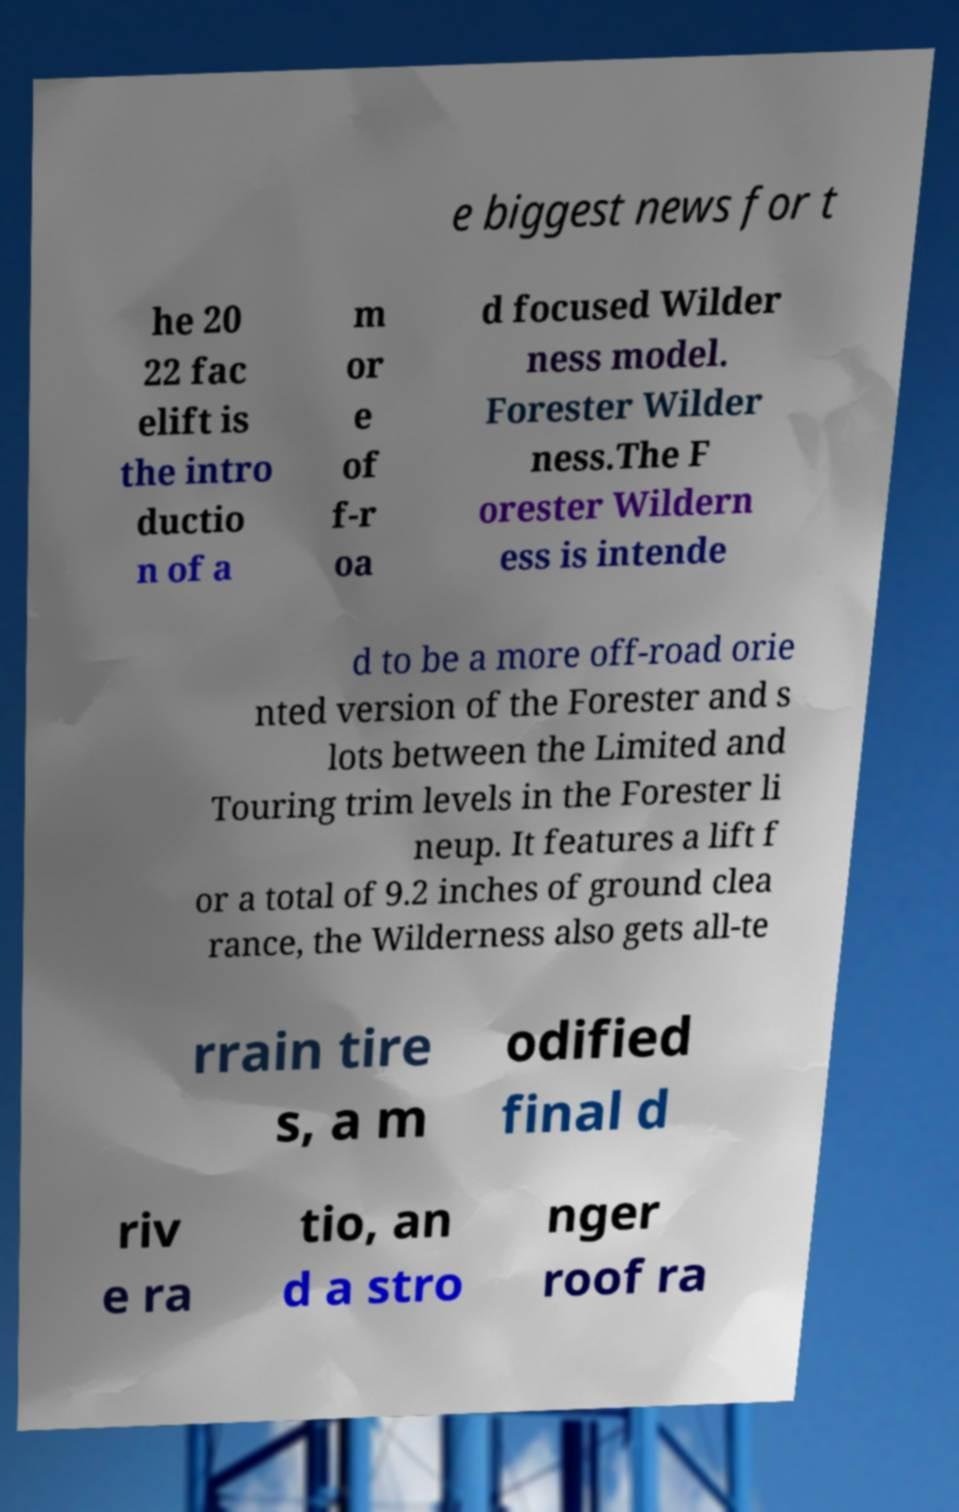Please identify and transcribe the text found in this image. e biggest news for t he 20 22 fac elift is the intro ductio n of a m or e of f-r oa d focused Wilder ness model. Forester Wilder ness.The F orester Wildern ess is intende d to be a more off-road orie nted version of the Forester and s lots between the Limited and Touring trim levels in the Forester li neup. It features a lift f or a total of 9.2 inches of ground clea rance, the Wilderness also gets all-te rrain tire s, a m odified final d riv e ra tio, an d a stro nger roof ra 